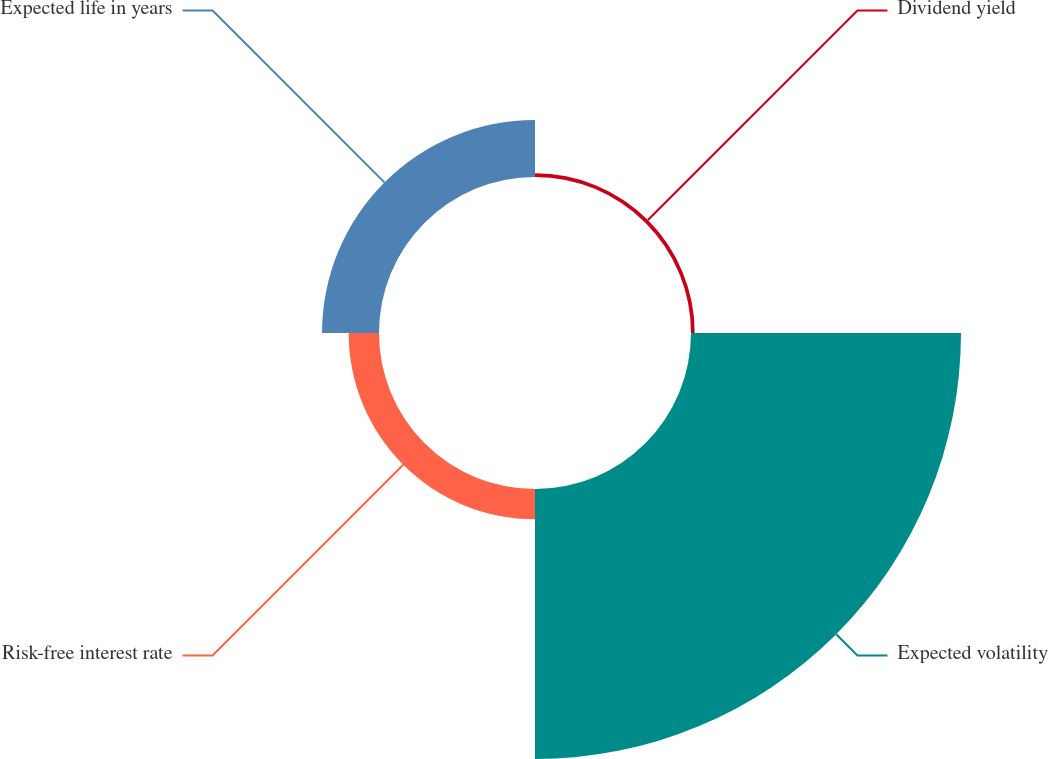Convert chart. <chart><loc_0><loc_0><loc_500><loc_500><pie_chart><fcel>Dividend yield<fcel>Expected volatility<fcel>Risk-free interest rate<fcel>Expected life in years<nl><fcel>1.03%<fcel>74.78%<fcel>8.41%<fcel>15.78%<nl></chart> 